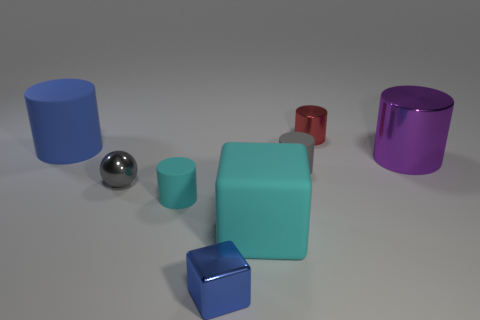What number of other things are there of the same shape as the big metal thing?
Provide a succinct answer. 4. Are there more spheres that are left of the tiny cube than big brown metal cylinders?
Ensure brevity in your answer.  Yes. What size is the red thing that is the same shape as the large purple object?
Offer a terse response. Small. What is the shape of the red metallic object?
Your response must be concise. Cylinder. There is a cyan matte object that is the same size as the red cylinder; what shape is it?
Offer a terse response. Cylinder. Is there any other thing that has the same color as the large shiny cylinder?
Provide a succinct answer. No. There is a block that is made of the same material as the big blue object; what is its size?
Provide a short and direct response. Large. There is a red metal thing; does it have the same shape as the large matte object right of the large blue rubber cylinder?
Provide a short and direct response. No. The cyan matte cube has what size?
Your answer should be compact. Large. Is the number of tiny blue cubes that are behind the tiny shiny cylinder less than the number of gray shiny spheres?
Ensure brevity in your answer.  Yes. 